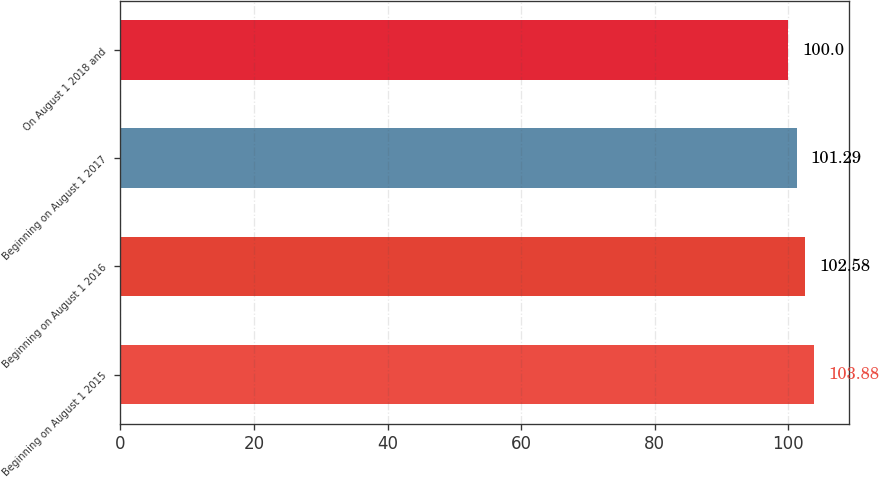Convert chart to OTSL. <chart><loc_0><loc_0><loc_500><loc_500><bar_chart><fcel>Beginning on August 1 2015<fcel>Beginning on August 1 2016<fcel>Beginning on August 1 2017<fcel>On August 1 2018 and<nl><fcel>103.88<fcel>102.58<fcel>101.29<fcel>100<nl></chart> 